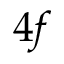<formula> <loc_0><loc_0><loc_500><loc_500>4 f</formula> 